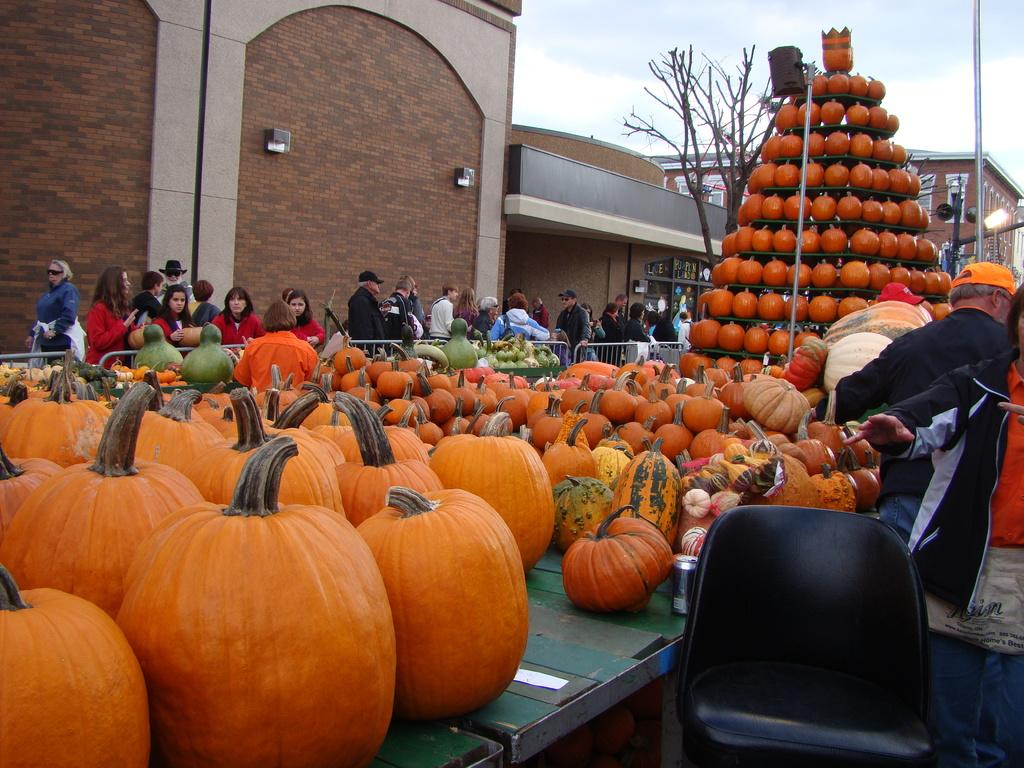What type of vegetation is present in the image? There are pumpkins in the image. What type of furniture is visible in the image? There is a chair in the image. What type of structure is present in the image? There is a wall in the image. What type of buildings can be seen in the image? There are buildings with windows in the image. What type of vertical structures are present in the image? There are poles in the image. What type of natural element is present in the image? There is a tree in the image. What type of group is present in the image? There is a group of people in the image. What is visible in the background of the image? The sky with clouds is visible in the background of the image. What type of art can be seen on the back of the page in the image? There is no page or art present in the image. What type of creature is walking in the background of the image? There are no creatures or walking actions depicted in the image. 